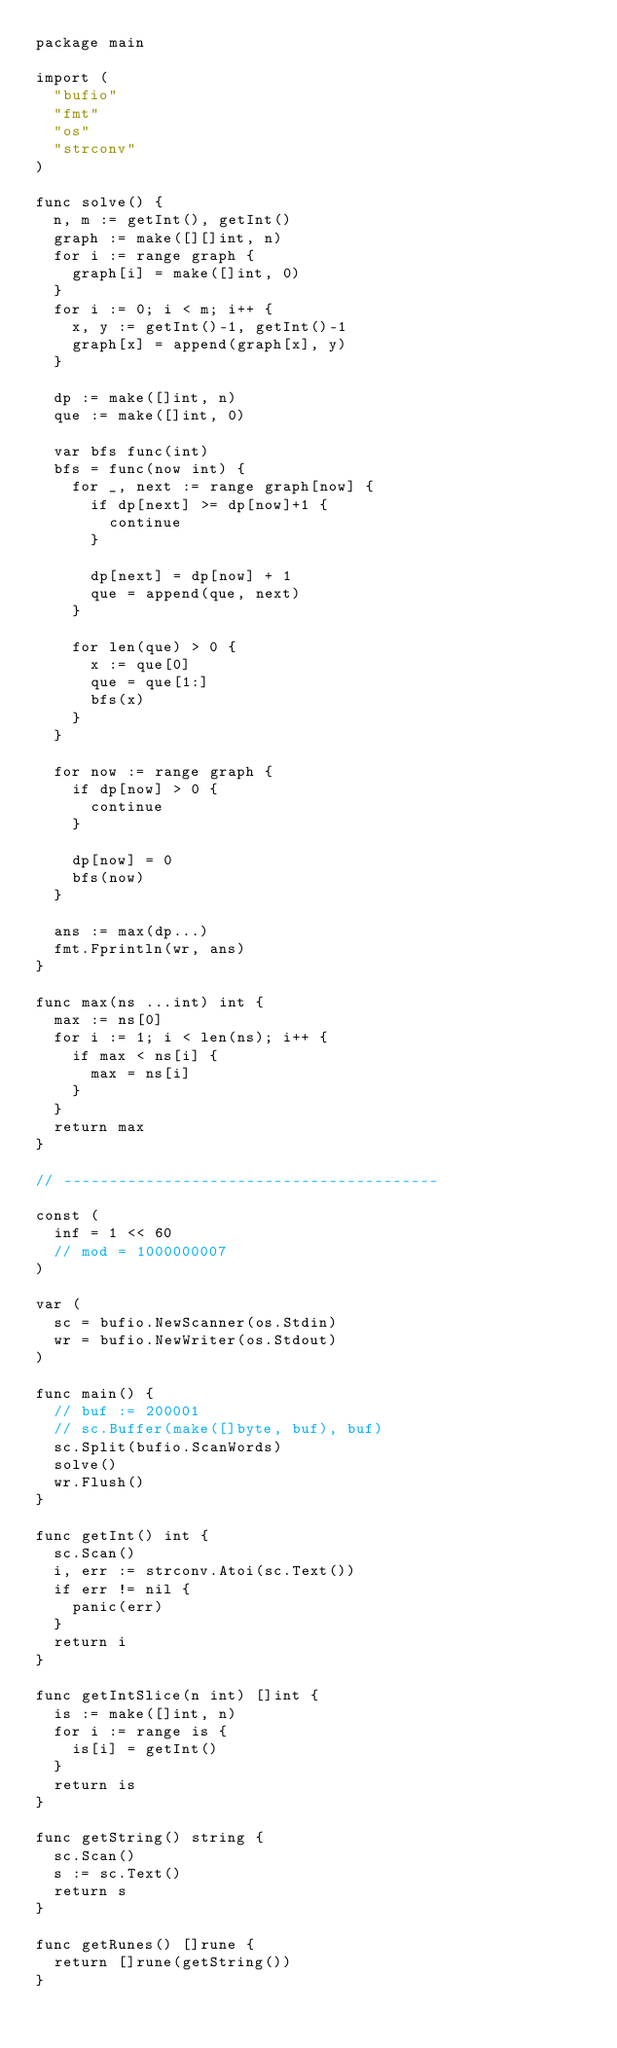<code> <loc_0><loc_0><loc_500><loc_500><_Go_>package main

import (
	"bufio"
	"fmt"
	"os"
	"strconv"
)

func solve() {
	n, m := getInt(), getInt()
	graph := make([][]int, n)
	for i := range graph {
		graph[i] = make([]int, 0)
	}
	for i := 0; i < m; i++ {
		x, y := getInt()-1, getInt()-1
		graph[x] = append(graph[x], y)
	}

	dp := make([]int, n)
	que := make([]int, 0)

	var bfs func(int)
	bfs = func(now int) {
		for _, next := range graph[now] {
			if dp[next] >= dp[now]+1 {
				continue
			}

			dp[next] = dp[now] + 1
			que = append(que, next)
		}

		for len(que) > 0 {
			x := que[0]
			que = que[1:]
			bfs(x)
		}
	}

	for now := range graph {
		if dp[now] > 0 {
			continue
		}

		dp[now] = 0
		bfs(now)
	}

	ans := max(dp...)
	fmt.Fprintln(wr, ans)
}

func max(ns ...int) int {
	max := ns[0]
	for i := 1; i < len(ns); i++ {
		if max < ns[i] {
			max = ns[i]
		}
	}
	return max
}

// -----------------------------------------

const (
	inf = 1 << 60
	// mod = 1000000007
)

var (
	sc = bufio.NewScanner(os.Stdin)
	wr = bufio.NewWriter(os.Stdout)
)

func main() {
	// buf := 200001
	// sc.Buffer(make([]byte, buf), buf)
	sc.Split(bufio.ScanWords)
	solve()
	wr.Flush()
}

func getInt() int {
	sc.Scan()
	i, err := strconv.Atoi(sc.Text())
	if err != nil {
		panic(err)
	}
	return i
}

func getIntSlice(n int) []int {
	is := make([]int, n)
	for i := range is {
		is[i] = getInt()
	}
	return is
}

func getString() string {
	sc.Scan()
	s := sc.Text()
	return s
}

func getRunes() []rune {
	return []rune(getString())
}
</code> 